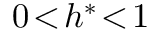Convert formula to latex. <formula><loc_0><loc_0><loc_500><loc_500>0 \, < \, h ^ { \ast } \, < \, 1</formula> 